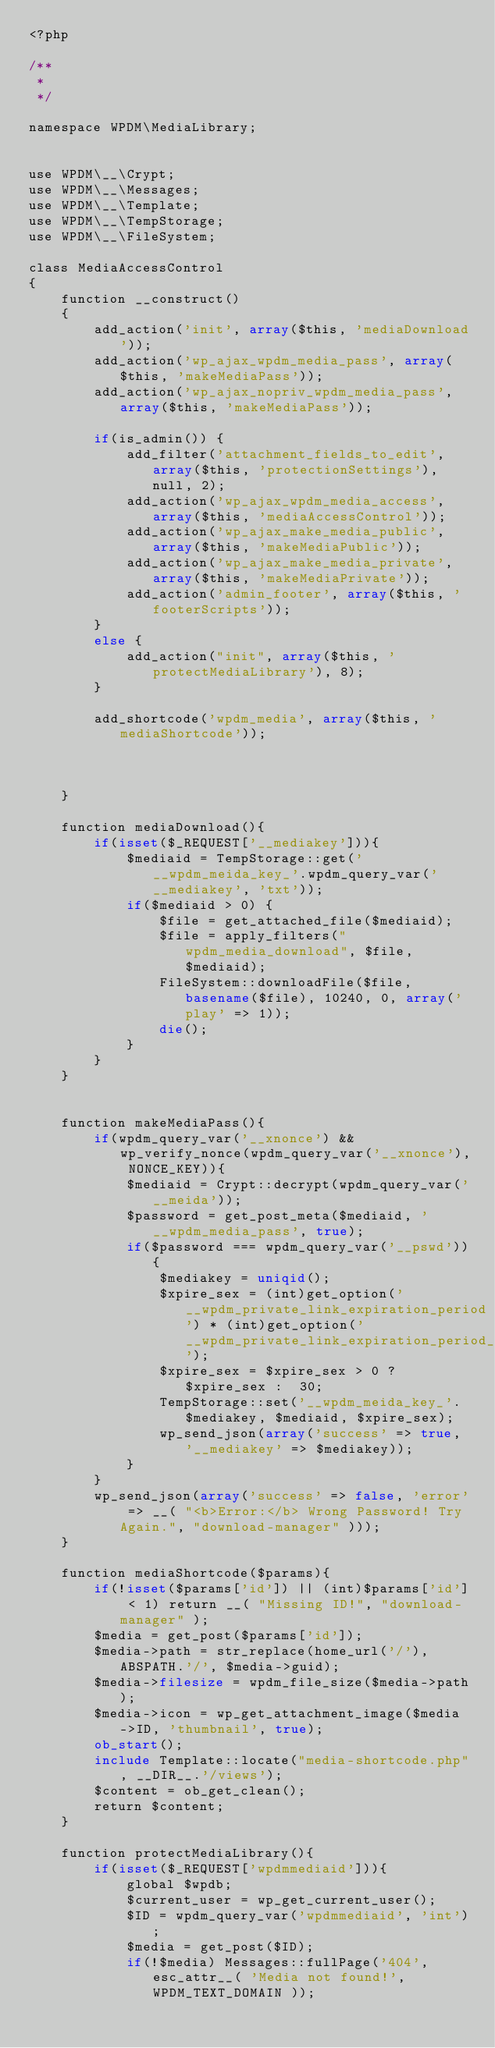Convert code to text. <code><loc_0><loc_0><loc_500><loc_500><_PHP_><?php

/**
 *
 */

namespace WPDM\MediaLibrary;


use WPDM\__\Crypt;
use WPDM\__\Messages;
use WPDM\__\Template;
use WPDM\__\TempStorage;
use WPDM\__\FileSystem;

class MediaAccessControl
{
    function __construct()
    {
        add_action('init', array($this, 'mediaDownload'));
        add_action('wp_ajax_wpdm_media_pass', array($this, 'makeMediaPass'));
        add_action('wp_ajax_nopriv_wpdm_media_pass', array($this, 'makeMediaPass'));

        if(is_admin()) {
            add_filter('attachment_fields_to_edit', array($this, 'protectionSettings'), null, 2);
            add_action('wp_ajax_wpdm_media_access', array($this, 'mediaAccessControl'));
            add_action('wp_ajax_make_media_public', array($this, 'makeMediaPublic'));
            add_action('wp_ajax_make_media_private', array($this, 'makeMediaPrivate'));
            add_action('admin_footer', array($this, 'footerScripts'));
        }
        else {
            add_action("init", array($this, 'protectMediaLibrary'), 8);
        }

        add_shortcode('wpdm_media', array($this, 'mediaShortcode'));



    }

    function mediaDownload(){
        if(isset($_REQUEST['__mediakey'])){
            $mediaid = TempStorage::get('__wpdm_meida_key_'.wpdm_query_var('__mediakey', 'txt'));
            if($mediaid > 0) {
                $file = get_attached_file($mediaid);
                $file = apply_filters("wpdm_media_download", $file, $mediaid);
                FileSystem::downloadFile($file, basename($file), 10240, 0, array('play' => 1));
                die();
            }
        }
    }


    function makeMediaPass(){
        if(wpdm_query_var('__xnonce') && wp_verify_nonce(wpdm_query_var('__xnonce'), NONCE_KEY)){
            $mediaid = Crypt::decrypt(wpdm_query_var('__meida'));
            $password = get_post_meta($mediaid, '__wpdm_media_pass', true);
            if($password === wpdm_query_var('__pswd')){
                $mediakey = uniqid();
                $xpire_sex = (int)get_option('__wpdm_private_link_expiration_period') * (int)get_option('__wpdm_private_link_expiration_period_unit');
                $xpire_sex = $xpire_sex > 0 ? $xpire_sex :  30;
                TempStorage::set('__wpdm_meida_key_'.$mediakey, $mediaid, $xpire_sex);
                wp_send_json(array('success' => true, '__mediakey' => $mediakey));
            }
        }
        wp_send_json(array('success' => false, 'error' => __( "<b>Error:</b> Wrong Password! Try Again.", "download-manager" )));
    }

    function mediaShortcode($params){
        if(!isset($params['id']) || (int)$params['id'] < 1) return __( "Missing ID!", "download-manager" );
        $media = get_post($params['id']);
        $media->path = str_replace(home_url('/'), ABSPATH.'/', $media->guid);
        $media->filesize = wpdm_file_size($media->path);
        $media->icon = wp_get_attachment_image($media->ID, 'thumbnail', true);
        ob_start();
        include Template::locate("media-shortcode.php", __DIR__.'/views');
        $content = ob_get_clean();
        return $content;
    }

    function protectMediaLibrary(){
        if(isset($_REQUEST['wpdmmediaid'])){
            global $wpdb;
            $current_user = wp_get_current_user();
            $ID = wpdm_query_var('wpdmmediaid', 'int');
            $media = get_post($ID);
            if(!$media) Messages::fullPage('404', esc_attr__( 'Media not found!', WPDM_TEXT_DOMAIN ));</code> 